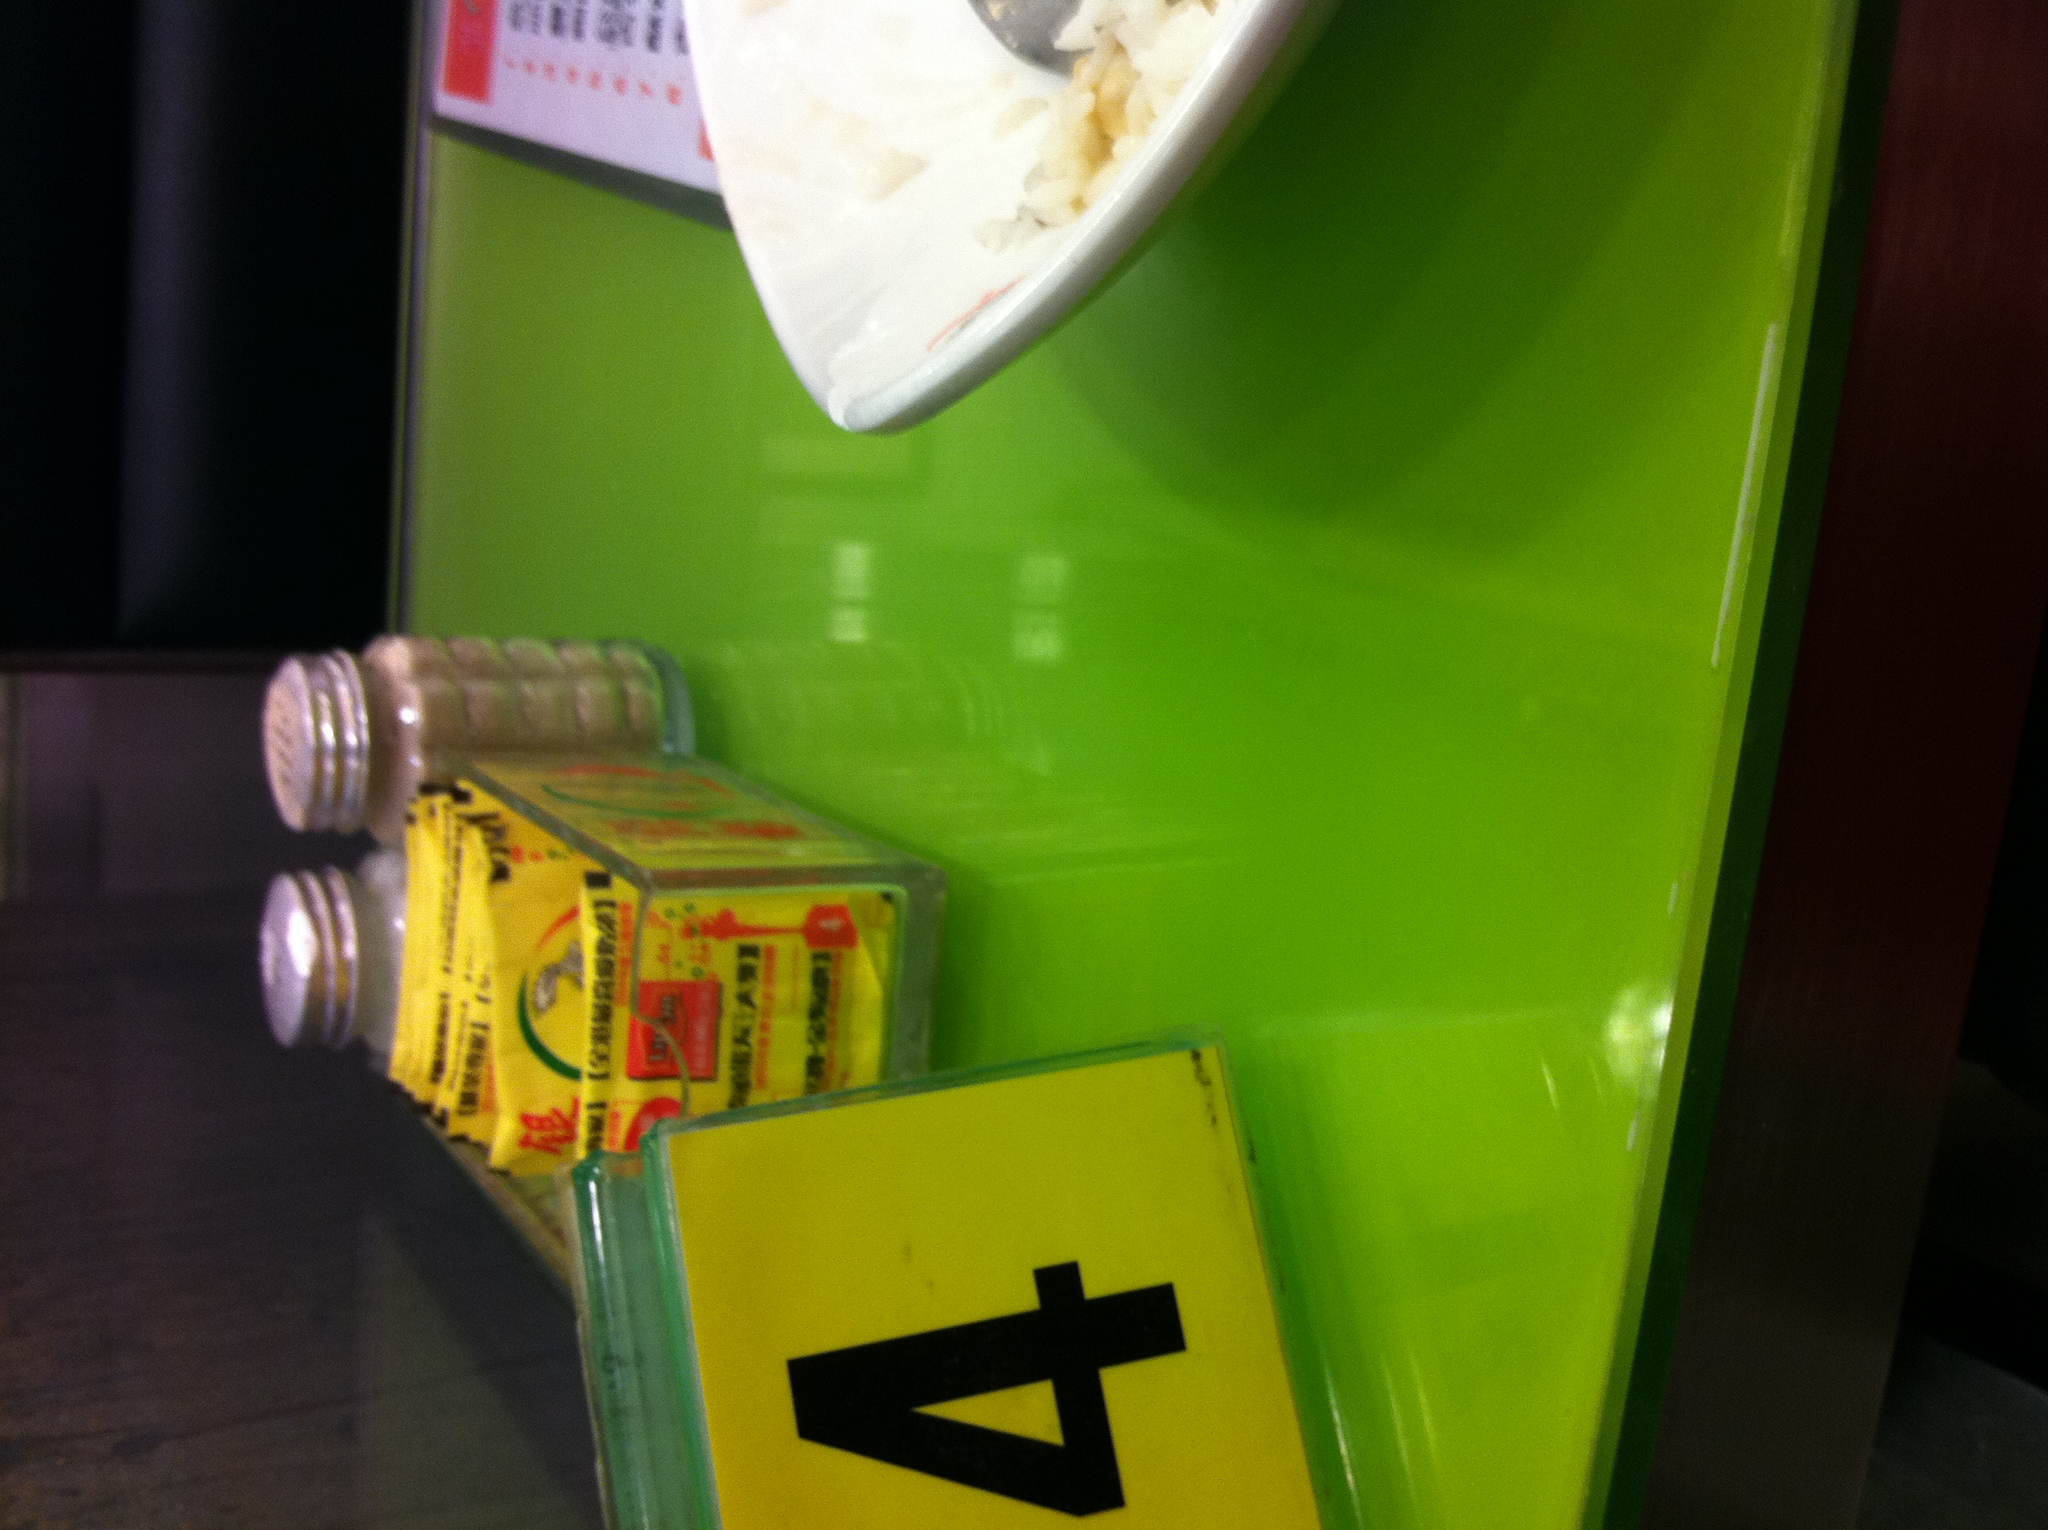What is the number of the table? What is the number of the table? Thank you. The number of the table shown in the image is 4. 